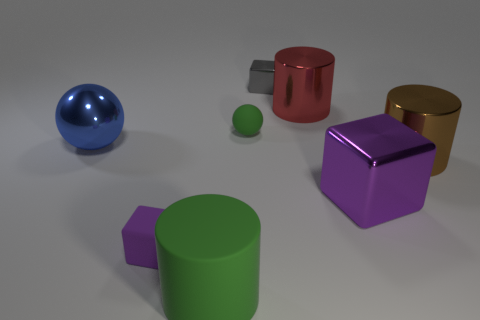Is there a large cylinder of the same color as the small metal block?
Make the answer very short. No. How many large objects are either purple cylinders or red shiny things?
Provide a succinct answer. 1. Is the material of the large cylinder in front of the small purple rubber object the same as the large purple block?
Provide a short and direct response. No. What shape is the purple thing that is to the right of the large metallic cylinder behind the thing that is to the right of the large shiny cube?
Make the answer very short. Cube. How many blue objects are either small rubber balls or large spheres?
Offer a terse response. 1. Are there an equal number of big brown cylinders that are in front of the large purple thing and gray metal things in front of the big red object?
Provide a short and direct response. Yes. There is a green rubber thing that is in front of the large metal cube; is it the same shape as the metal thing to the left of the small gray metallic object?
Offer a terse response. No. Are there any other things that are the same shape as the purple shiny thing?
Provide a short and direct response. Yes. What shape is the large red thing that is made of the same material as the brown cylinder?
Your answer should be very brief. Cylinder. Is the number of green cylinders on the left side of the brown shiny cylinder the same as the number of tiny brown matte cubes?
Your response must be concise. No. 